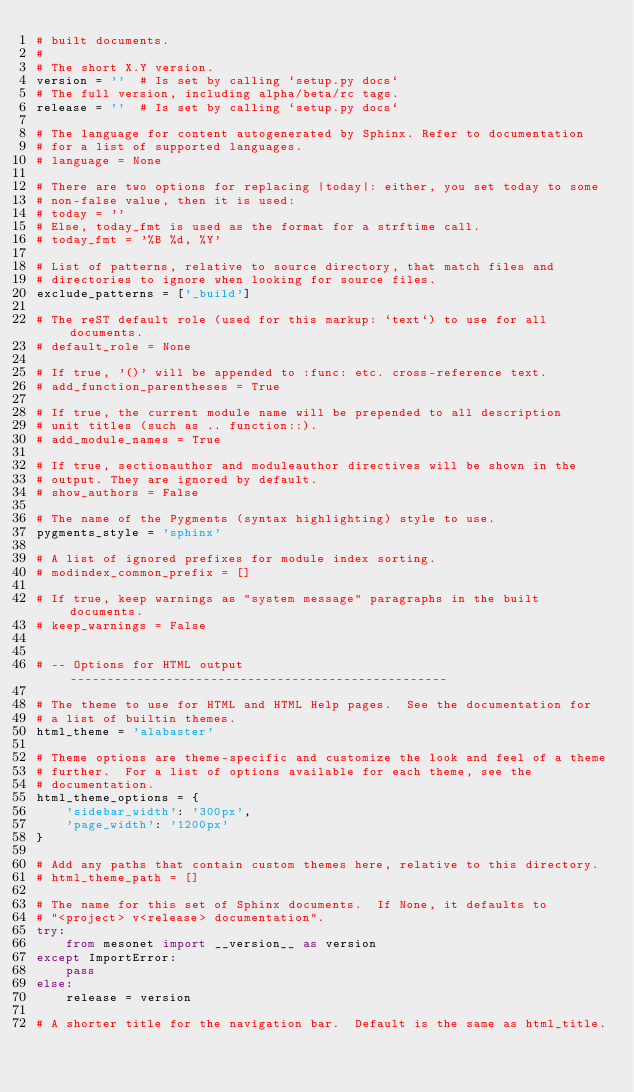Convert code to text. <code><loc_0><loc_0><loc_500><loc_500><_Python_># built documents.
#
# The short X.Y version.
version = ''  # Is set by calling `setup.py docs`
# The full version, including alpha/beta/rc tags.
release = ''  # Is set by calling `setup.py docs`

# The language for content autogenerated by Sphinx. Refer to documentation
# for a list of supported languages.
# language = None

# There are two options for replacing |today|: either, you set today to some
# non-false value, then it is used:
# today = ''
# Else, today_fmt is used as the format for a strftime call.
# today_fmt = '%B %d, %Y'

# List of patterns, relative to source directory, that match files and
# directories to ignore when looking for source files.
exclude_patterns = ['_build']

# The reST default role (used for this markup: `text`) to use for all documents.
# default_role = None

# If true, '()' will be appended to :func: etc. cross-reference text.
# add_function_parentheses = True

# If true, the current module name will be prepended to all description
# unit titles (such as .. function::).
# add_module_names = True

# If true, sectionauthor and moduleauthor directives will be shown in the
# output. They are ignored by default.
# show_authors = False

# The name of the Pygments (syntax highlighting) style to use.
pygments_style = 'sphinx'

# A list of ignored prefixes for module index sorting.
# modindex_common_prefix = []

# If true, keep warnings as "system message" paragraphs in the built documents.
# keep_warnings = False


# -- Options for HTML output ---------------------------------------------------

# The theme to use for HTML and HTML Help pages.  See the documentation for
# a list of builtin themes.
html_theme = 'alabaster'

# Theme options are theme-specific and customize the look and feel of a theme
# further.  For a list of options available for each theme, see the
# documentation.
html_theme_options = {
    'sidebar_width': '300px',
    'page_width': '1200px'
}

# Add any paths that contain custom themes here, relative to this directory.
# html_theme_path = []

# The name for this set of Sphinx documents.  If None, it defaults to
# "<project> v<release> documentation".
try:
    from mesonet import __version__ as version
except ImportError:
    pass
else:
    release = version

# A shorter title for the navigation bar.  Default is the same as html_title.</code> 